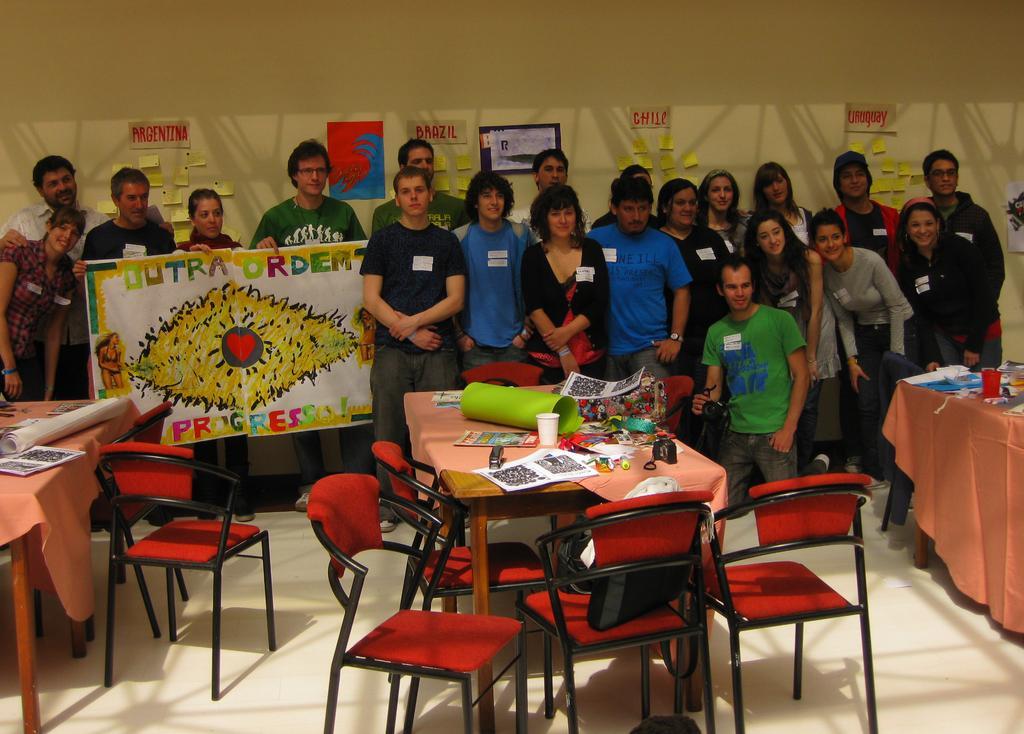Describe this image in one or two sentences. Posters on wall. These persons are standing. These three persons are holding a poster. On this tables there are cups, chart and things. We can able to see red chair. 